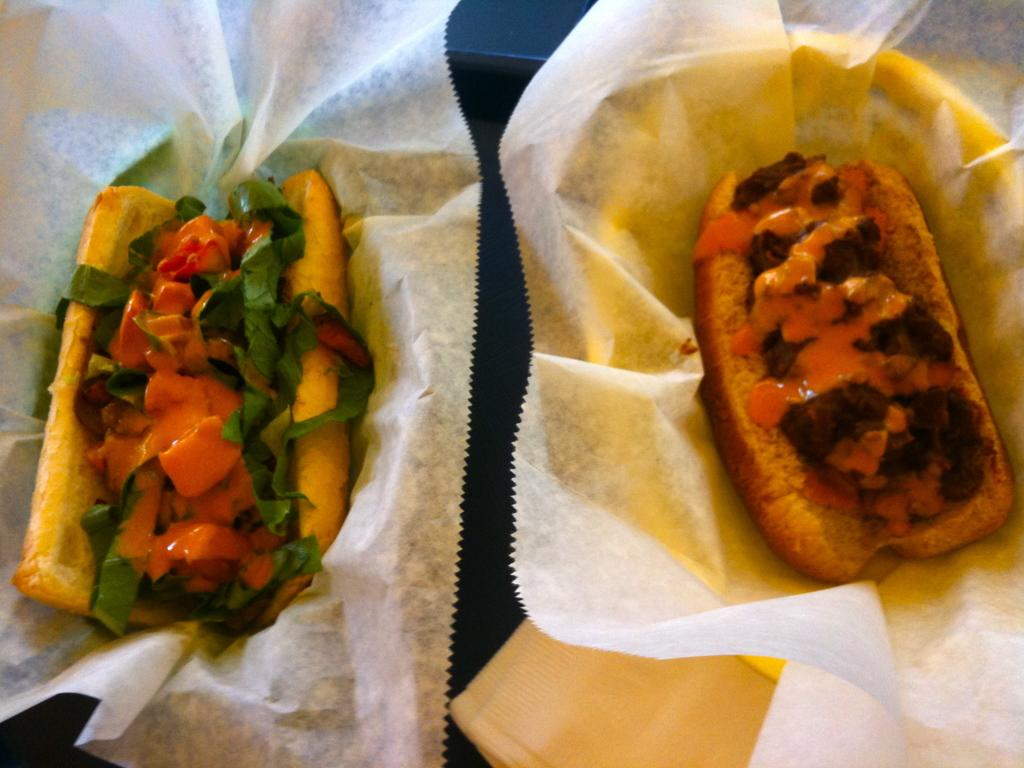What are the two different food items in the image? Unfortunately, the provided facts do not specify the types of food items in the image. How are the food items being stored or presented in the image? The food items are kept in a white-colored tissue paper. What type of vegetable can be seen growing in the image? There is no vegetable present in the image. What type of yarn is being used to decorate the bedroom in the image? There is no bedroom or yarn present in the image. 